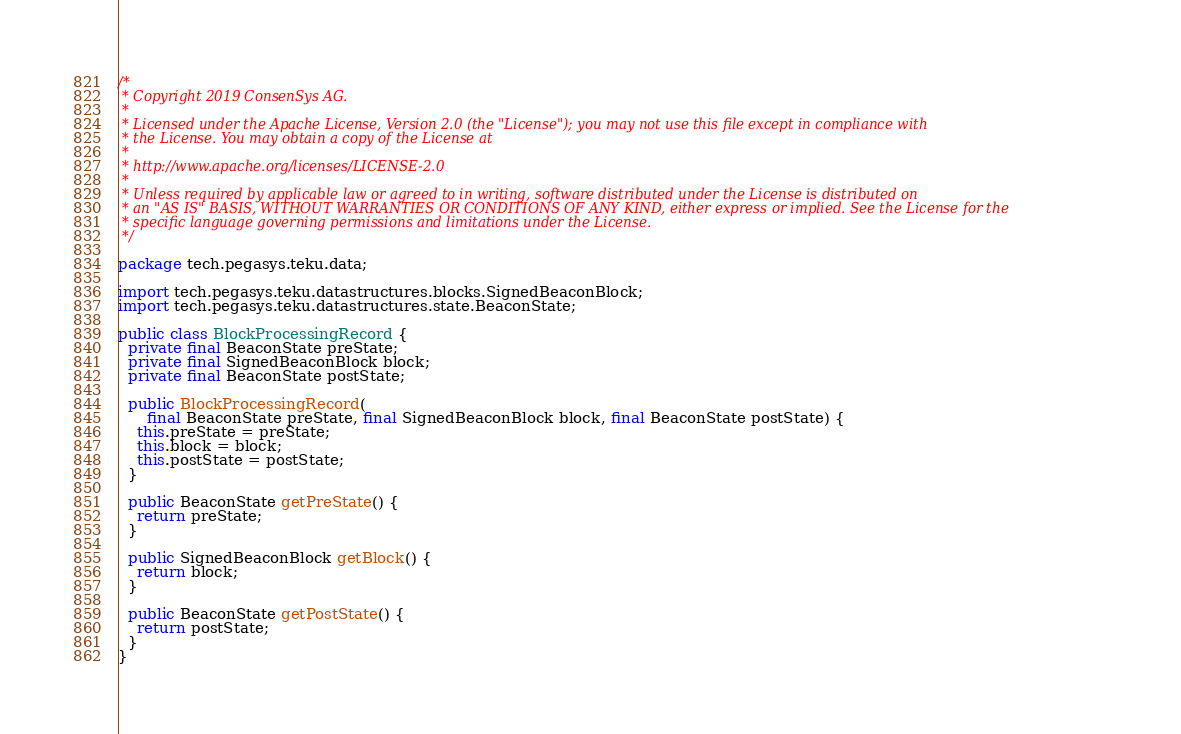Convert code to text. <code><loc_0><loc_0><loc_500><loc_500><_Java_>/*
 * Copyright 2019 ConsenSys AG.
 *
 * Licensed under the Apache License, Version 2.0 (the "License"); you may not use this file except in compliance with
 * the License. You may obtain a copy of the License at
 *
 * http://www.apache.org/licenses/LICENSE-2.0
 *
 * Unless required by applicable law or agreed to in writing, software distributed under the License is distributed on
 * an "AS IS" BASIS, WITHOUT WARRANTIES OR CONDITIONS OF ANY KIND, either express or implied. See the License for the
 * specific language governing permissions and limitations under the License.
 */

package tech.pegasys.teku.data;

import tech.pegasys.teku.datastructures.blocks.SignedBeaconBlock;
import tech.pegasys.teku.datastructures.state.BeaconState;

public class BlockProcessingRecord {
  private final BeaconState preState;
  private final SignedBeaconBlock block;
  private final BeaconState postState;

  public BlockProcessingRecord(
      final BeaconState preState, final SignedBeaconBlock block, final BeaconState postState) {
    this.preState = preState;
    this.block = block;
    this.postState = postState;
  }

  public BeaconState getPreState() {
    return preState;
  }

  public SignedBeaconBlock getBlock() {
    return block;
  }

  public BeaconState getPostState() {
    return postState;
  }
}
</code> 